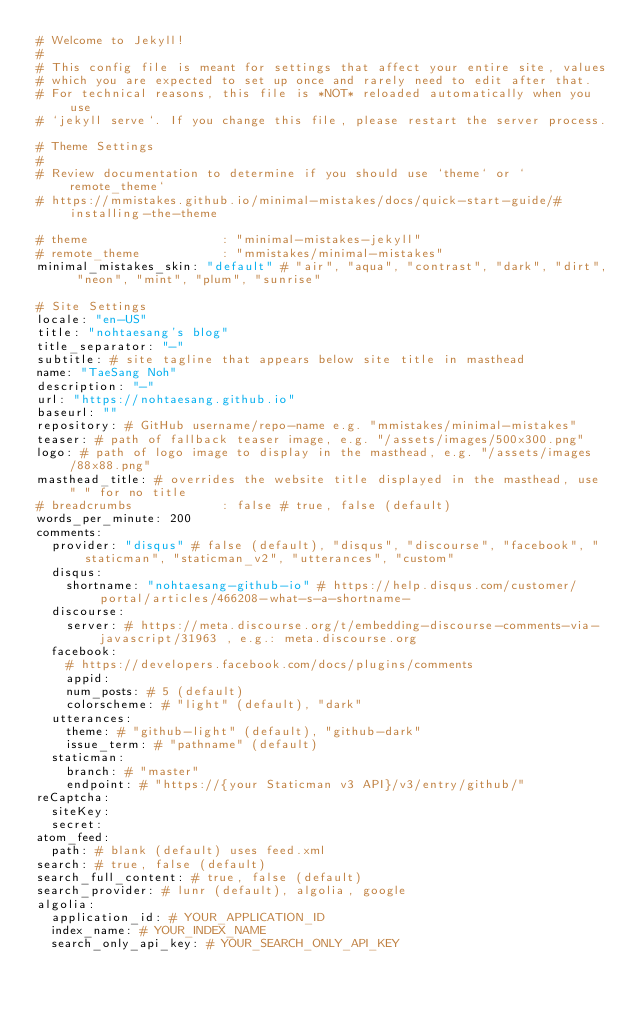Convert code to text. <code><loc_0><loc_0><loc_500><loc_500><_YAML_># Welcome to Jekyll!
#
# This config file is meant for settings that affect your entire site, values
# which you are expected to set up once and rarely need to edit after that.
# For technical reasons, this file is *NOT* reloaded automatically when you use
# `jekyll serve`. If you change this file, please restart the server process.

# Theme Settings
#
# Review documentation to determine if you should use `theme` or `remote_theme`
# https://mmistakes.github.io/minimal-mistakes/docs/quick-start-guide/#installing-the-theme

# theme                  : "minimal-mistakes-jekyll"
# remote_theme           : "mmistakes/minimal-mistakes"
minimal_mistakes_skin: "default" # "air", "aqua", "contrast", "dark", "dirt", "neon", "mint", "plum", "sunrise"

# Site Settings
locale: "en-US"
title: "nohtaesang's blog"
title_separator: "-"
subtitle: # site tagline that appears below site title in masthead
name: "TaeSang Noh"
description: "-"
url: "https://nohtaesang.github.io"
baseurl: ""
repository: # GitHub username/repo-name e.g. "mmistakes/minimal-mistakes"
teaser: # path of fallback teaser image, e.g. "/assets/images/500x300.png"
logo: # path of logo image to display in the masthead, e.g. "/assets/images/88x88.png"
masthead_title: # overrides the website title displayed in the masthead, use " " for no title
# breadcrumbs            : false # true, false (default)
words_per_minute: 200
comments:
  provider: "disqus" # false (default), "disqus", "discourse", "facebook", "staticman", "staticman_v2", "utterances", "custom"
  disqus:
    shortname: "nohtaesang-github-io" # https://help.disqus.com/customer/portal/articles/466208-what-s-a-shortname-
  discourse:
    server: # https://meta.discourse.org/t/embedding-discourse-comments-via-javascript/31963 , e.g.: meta.discourse.org
  facebook:
    # https://developers.facebook.com/docs/plugins/comments
    appid:
    num_posts: # 5 (default)
    colorscheme: # "light" (default), "dark"
  utterances:
    theme: # "github-light" (default), "github-dark"
    issue_term: # "pathname" (default)
  staticman:
    branch: # "master"
    endpoint: # "https://{your Staticman v3 API}/v3/entry/github/"
reCaptcha:
  siteKey:
  secret:
atom_feed:
  path: # blank (default) uses feed.xml
search: # true, false (default)
search_full_content: # true, false (default)
search_provider: # lunr (default), algolia, google
algolia:
  application_id: # YOUR_APPLICATION_ID
  index_name: # YOUR_INDEX_NAME
  search_only_api_key: # YOUR_SEARCH_ONLY_API_KEY</code> 